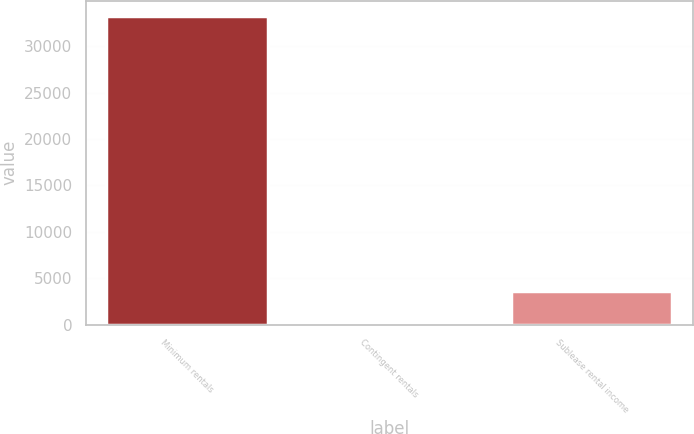Convert chart to OTSL. <chart><loc_0><loc_0><loc_500><loc_500><bar_chart><fcel>Minimum rentals<fcel>Contingent rentals<fcel>Sublease rental income<nl><fcel>33201<fcel>284<fcel>3575.7<nl></chart> 